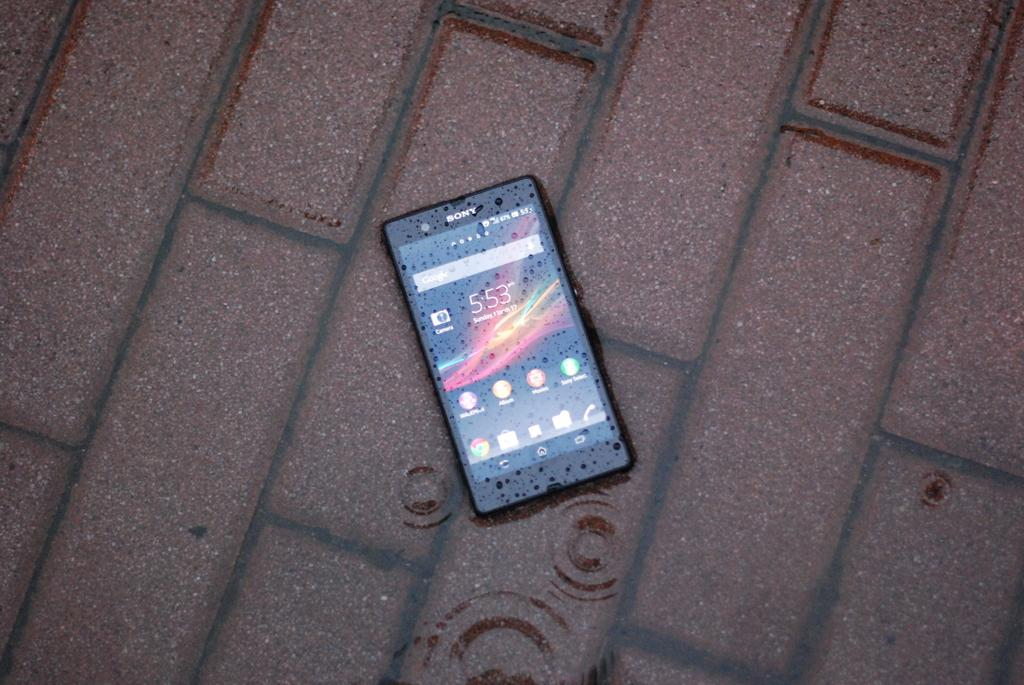<image>
Give a short and clear explanation of the subsequent image. A Sony cell phone sits abandoned and wet on a rainy sidewalk. 